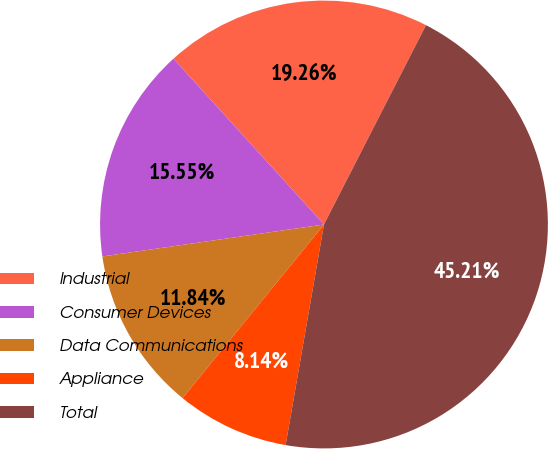Convert chart to OTSL. <chart><loc_0><loc_0><loc_500><loc_500><pie_chart><fcel>Industrial<fcel>Consumer Devices<fcel>Data Communications<fcel>Appliance<fcel>Total<nl><fcel>19.26%<fcel>15.55%<fcel>11.84%<fcel>8.14%<fcel>45.21%<nl></chart> 